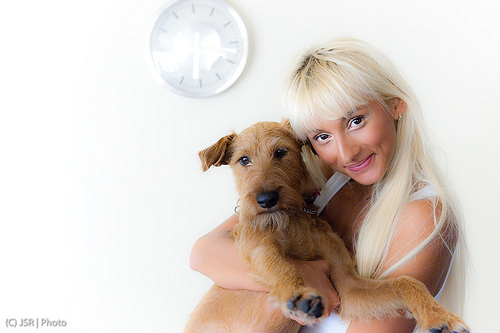<image>
Can you confirm if the dog is behind the woman? No. The dog is not behind the woman. From this viewpoint, the dog appears to be positioned elsewhere in the scene. Where is the dog in relation to the girl? Is it to the right of the girl? No. The dog is not to the right of the girl. The horizontal positioning shows a different relationship. 